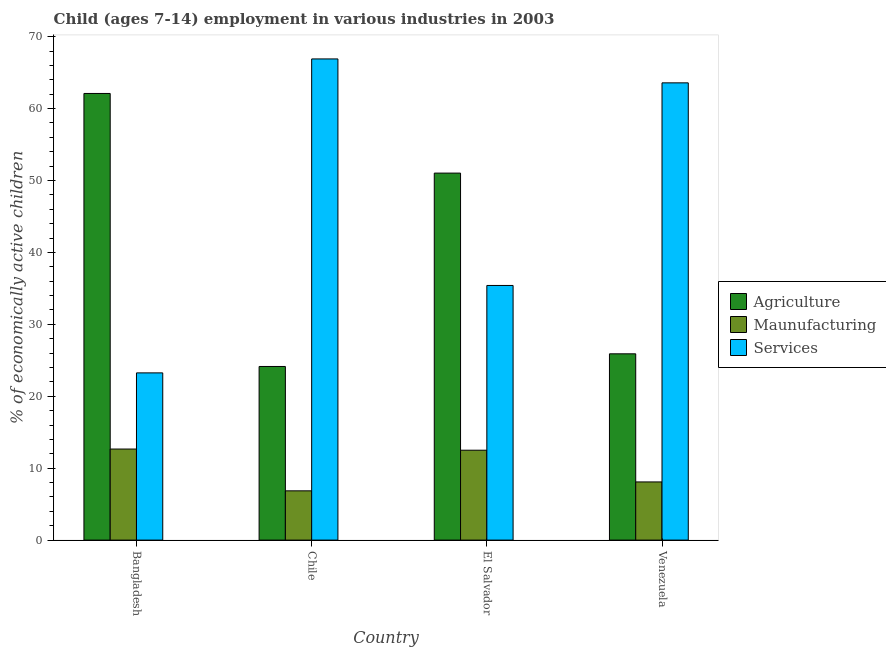How many different coloured bars are there?
Offer a terse response. 3. What is the label of the 2nd group of bars from the left?
Your answer should be compact. Chile. What is the percentage of economically active children in services in El Salvador?
Your answer should be compact. 35.4. Across all countries, what is the maximum percentage of economically active children in agriculture?
Your response must be concise. 62.1. Across all countries, what is the minimum percentage of economically active children in agriculture?
Your response must be concise. 24.14. In which country was the percentage of economically active children in agriculture minimum?
Make the answer very short. Chile. What is the total percentage of economically active children in agriculture in the graph?
Keep it short and to the point. 163.17. What is the difference between the percentage of economically active children in services in Chile and that in El Salvador?
Your answer should be compact. 31.5. What is the difference between the percentage of economically active children in agriculture in Chile and the percentage of economically active children in manufacturing in Venezuela?
Give a very brief answer. 16.05. What is the average percentage of economically active children in agriculture per country?
Your response must be concise. 40.79. What is the difference between the percentage of economically active children in services and percentage of economically active children in agriculture in Bangladesh?
Ensure brevity in your answer.  -38.85. In how many countries, is the percentage of economically active children in agriculture greater than 14 %?
Provide a short and direct response. 4. What is the ratio of the percentage of economically active children in agriculture in El Salvador to that in Venezuela?
Provide a succinct answer. 1.97. Is the percentage of economically active children in agriculture in Chile less than that in El Salvador?
Your answer should be very brief. Yes. Is the difference between the percentage of economically active children in manufacturing in Chile and Venezuela greater than the difference between the percentage of economically active children in agriculture in Chile and Venezuela?
Offer a terse response. Yes. What is the difference between the highest and the second highest percentage of economically active children in manufacturing?
Your response must be concise. 0.16. What is the difference between the highest and the lowest percentage of economically active children in agriculture?
Your response must be concise. 37.96. In how many countries, is the percentage of economically active children in manufacturing greater than the average percentage of economically active children in manufacturing taken over all countries?
Provide a short and direct response. 2. Is the sum of the percentage of economically active children in manufacturing in Bangladesh and Chile greater than the maximum percentage of economically active children in agriculture across all countries?
Your answer should be compact. No. What does the 1st bar from the left in Bangladesh represents?
Your response must be concise. Agriculture. What does the 2nd bar from the right in Venezuela represents?
Your answer should be very brief. Maunufacturing. Are all the bars in the graph horizontal?
Your answer should be very brief. No. How many countries are there in the graph?
Offer a terse response. 4. What is the difference between two consecutive major ticks on the Y-axis?
Provide a short and direct response. 10. Are the values on the major ticks of Y-axis written in scientific E-notation?
Make the answer very short. No. What is the title of the graph?
Make the answer very short. Child (ages 7-14) employment in various industries in 2003. Does "Other sectors" appear as one of the legend labels in the graph?
Provide a succinct answer. No. What is the label or title of the X-axis?
Offer a terse response. Country. What is the label or title of the Y-axis?
Ensure brevity in your answer.  % of economically active children. What is the % of economically active children of Agriculture in Bangladesh?
Your answer should be compact. 62.1. What is the % of economically active children in Maunufacturing in Bangladesh?
Offer a very short reply. 12.66. What is the % of economically active children of Services in Bangladesh?
Provide a short and direct response. 23.25. What is the % of economically active children in Agriculture in Chile?
Your response must be concise. 24.14. What is the % of economically active children in Maunufacturing in Chile?
Your response must be concise. 6.85. What is the % of economically active children of Services in Chile?
Provide a short and direct response. 66.9. What is the % of economically active children of Agriculture in El Salvador?
Provide a succinct answer. 51.03. What is the % of economically active children of Maunufacturing in El Salvador?
Your response must be concise. 12.5. What is the % of economically active children in Services in El Salvador?
Ensure brevity in your answer.  35.4. What is the % of economically active children of Agriculture in Venezuela?
Provide a succinct answer. 25.9. What is the % of economically active children of Maunufacturing in Venezuela?
Keep it short and to the point. 8.09. What is the % of economically active children of Services in Venezuela?
Provide a succinct answer. 63.57. Across all countries, what is the maximum % of economically active children of Agriculture?
Your response must be concise. 62.1. Across all countries, what is the maximum % of economically active children in Maunufacturing?
Ensure brevity in your answer.  12.66. Across all countries, what is the maximum % of economically active children in Services?
Give a very brief answer. 66.9. Across all countries, what is the minimum % of economically active children in Agriculture?
Keep it short and to the point. 24.14. Across all countries, what is the minimum % of economically active children of Maunufacturing?
Make the answer very short. 6.85. Across all countries, what is the minimum % of economically active children in Services?
Make the answer very short. 23.25. What is the total % of economically active children in Agriculture in the graph?
Make the answer very short. 163.17. What is the total % of economically active children in Maunufacturing in the graph?
Provide a short and direct response. 40.1. What is the total % of economically active children in Services in the graph?
Ensure brevity in your answer.  189.13. What is the difference between the % of economically active children of Agriculture in Bangladesh and that in Chile?
Give a very brief answer. 37.96. What is the difference between the % of economically active children of Maunufacturing in Bangladesh and that in Chile?
Ensure brevity in your answer.  5.81. What is the difference between the % of economically active children of Services in Bangladesh and that in Chile?
Provide a short and direct response. -43.65. What is the difference between the % of economically active children in Agriculture in Bangladesh and that in El Salvador?
Ensure brevity in your answer.  11.07. What is the difference between the % of economically active children of Maunufacturing in Bangladesh and that in El Salvador?
Give a very brief answer. 0.16. What is the difference between the % of economically active children in Services in Bangladesh and that in El Salvador?
Make the answer very short. -12.15. What is the difference between the % of economically active children in Agriculture in Bangladesh and that in Venezuela?
Provide a succinct answer. 36.2. What is the difference between the % of economically active children in Maunufacturing in Bangladesh and that in Venezuela?
Offer a very short reply. 4.57. What is the difference between the % of economically active children of Services in Bangladesh and that in Venezuela?
Your answer should be very brief. -40.32. What is the difference between the % of economically active children of Agriculture in Chile and that in El Salvador?
Your response must be concise. -26.89. What is the difference between the % of economically active children of Maunufacturing in Chile and that in El Salvador?
Your answer should be very brief. -5.65. What is the difference between the % of economically active children of Services in Chile and that in El Salvador?
Make the answer very short. 31.5. What is the difference between the % of economically active children in Agriculture in Chile and that in Venezuela?
Give a very brief answer. -1.76. What is the difference between the % of economically active children in Maunufacturing in Chile and that in Venezuela?
Offer a terse response. -1.24. What is the difference between the % of economically active children of Services in Chile and that in Venezuela?
Your answer should be very brief. 3.33. What is the difference between the % of economically active children of Agriculture in El Salvador and that in Venezuela?
Give a very brief answer. 25.13. What is the difference between the % of economically active children in Maunufacturing in El Salvador and that in Venezuela?
Offer a very short reply. 4.41. What is the difference between the % of economically active children in Services in El Salvador and that in Venezuela?
Make the answer very short. -28.17. What is the difference between the % of economically active children of Agriculture in Bangladesh and the % of economically active children of Maunufacturing in Chile?
Ensure brevity in your answer.  55.25. What is the difference between the % of economically active children in Agriculture in Bangladesh and the % of economically active children in Services in Chile?
Provide a succinct answer. -4.8. What is the difference between the % of economically active children of Maunufacturing in Bangladesh and the % of economically active children of Services in Chile?
Offer a terse response. -54.24. What is the difference between the % of economically active children in Agriculture in Bangladesh and the % of economically active children in Maunufacturing in El Salvador?
Your answer should be very brief. 49.6. What is the difference between the % of economically active children in Agriculture in Bangladesh and the % of economically active children in Services in El Salvador?
Keep it short and to the point. 26.7. What is the difference between the % of economically active children in Maunufacturing in Bangladesh and the % of economically active children in Services in El Salvador?
Your answer should be very brief. -22.74. What is the difference between the % of economically active children of Agriculture in Bangladesh and the % of economically active children of Maunufacturing in Venezuela?
Provide a short and direct response. 54.01. What is the difference between the % of economically active children of Agriculture in Bangladesh and the % of economically active children of Services in Venezuela?
Your response must be concise. -1.47. What is the difference between the % of economically active children of Maunufacturing in Bangladesh and the % of economically active children of Services in Venezuela?
Provide a short and direct response. -50.91. What is the difference between the % of economically active children in Agriculture in Chile and the % of economically active children in Maunufacturing in El Salvador?
Give a very brief answer. 11.64. What is the difference between the % of economically active children in Agriculture in Chile and the % of economically active children in Services in El Salvador?
Offer a very short reply. -11.26. What is the difference between the % of economically active children of Maunufacturing in Chile and the % of economically active children of Services in El Salvador?
Your answer should be compact. -28.55. What is the difference between the % of economically active children of Agriculture in Chile and the % of economically active children of Maunufacturing in Venezuela?
Your answer should be compact. 16.05. What is the difference between the % of economically active children in Agriculture in Chile and the % of economically active children in Services in Venezuela?
Your answer should be compact. -39.43. What is the difference between the % of economically active children in Maunufacturing in Chile and the % of economically active children in Services in Venezuela?
Ensure brevity in your answer.  -56.72. What is the difference between the % of economically active children in Agriculture in El Salvador and the % of economically active children in Maunufacturing in Venezuela?
Give a very brief answer. 42.94. What is the difference between the % of economically active children in Agriculture in El Salvador and the % of economically active children in Services in Venezuela?
Offer a very short reply. -12.55. What is the difference between the % of economically active children in Maunufacturing in El Salvador and the % of economically active children in Services in Venezuela?
Your answer should be very brief. -51.07. What is the average % of economically active children in Agriculture per country?
Your answer should be compact. 40.79. What is the average % of economically active children in Maunufacturing per country?
Ensure brevity in your answer.  10.02. What is the average % of economically active children in Services per country?
Provide a succinct answer. 47.28. What is the difference between the % of economically active children of Agriculture and % of economically active children of Maunufacturing in Bangladesh?
Your answer should be very brief. 49.44. What is the difference between the % of economically active children of Agriculture and % of economically active children of Services in Bangladesh?
Offer a very short reply. 38.85. What is the difference between the % of economically active children in Maunufacturing and % of economically active children in Services in Bangladesh?
Ensure brevity in your answer.  -10.59. What is the difference between the % of economically active children of Agriculture and % of economically active children of Maunufacturing in Chile?
Offer a very short reply. 17.29. What is the difference between the % of economically active children of Agriculture and % of economically active children of Services in Chile?
Your answer should be compact. -42.76. What is the difference between the % of economically active children in Maunufacturing and % of economically active children in Services in Chile?
Ensure brevity in your answer.  -60.05. What is the difference between the % of economically active children in Agriculture and % of economically active children in Maunufacturing in El Salvador?
Your response must be concise. 38.53. What is the difference between the % of economically active children of Agriculture and % of economically active children of Services in El Salvador?
Offer a very short reply. 15.62. What is the difference between the % of economically active children of Maunufacturing and % of economically active children of Services in El Salvador?
Offer a very short reply. -22.9. What is the difference between the % of economically active children of Agriculture and % of economically active children of Maunufacturing in Venezuela?
Ensure brevity in your answer.  17.81. What is the difference between the % of economically active children of Agriculture and % of economically active children of Services in Venezuela?
Provide a short and direct response. -37.67. What is the difference between the % of economically active children of Maunufacturing and % of economically active children of Services in Venezuela?
Give a very brief answer. -55.49. What is the ratio of the % of economically active children of Agriculture in Bangladesh to that in Chile?
Ensure brevity in your answer.  2.57. What is the ratio of the % of economically active children in Maunufacturing in Bangladesh to that in Chile?
Offer a terse response. 1.85. What is the ratio of the % of economically active children in Services in Bangladesh to that in Chile?
Make the answer very short. 0.35. What is the ratio of the % of economically active children of Agriculture in Bangladesh to that in El Salvador?
Your answer should be very brief. 1.22. What is the ratio of the % of economically active children in Maunufacturing in Bangladesh to that in El Salvador?
Your response must be concise. 1.01. What is the ratio of the % of economically active children in Services in Bangladesh to that in El Salvador?
Ensure brevity in your answer.  0.66. What is the ratio of the % of economically active children of Agriculture in Bangladesh to that in Venezuela?
Your response must be concise. 2.4. What is the ratio of the % of economically active children in Maunufacturing in Bangladesh to that in Venezuela?
Keep it short and to the point. 1.57. What is the ratio of the % of economically active children of Services in Bangladesh to that in Venezuela?
Offer a very short reply. 0.37. What is the ratio of the % of economically active children of Agriculture in Chile to that in El Salvador?
Give a very brief answer. 0.47. What is the ratio of the % of economically active children of Maunufacturing in Chile to that in El Salvador?
Provide a succinct answer. 0.55. What is the ratio of the % of economically active children of Services in Chile to that in El Salvador?
Your answer should be compact. 1.89. What is the ratio of the % of economically active children in Agriculture in Chile to that in Venezuela?
Your answer should be compact. 0.93. What is the ratio of the % of economically active children in Maunufacturing in Chile to that in Venezuela?
Give a very brief answer. 0.85. What is the ratio of the % of economically active children of Services in Chile to that in Venezuela?
Provide a succinct answer. 1.05. What is the ratio of the % of economically active children in Agriculture in El Salvador to that in Venezuela?
Your response must be concise. 1.97. What is the ratio of the % of economically active children in Maunufacturing in El Salvador to that in Venezuela?
Your answer should be compact. 1.55. What is the ratio of the % of economically active children in Services in El Salvador to that in Venezuela?
Give a very brief answer. 0.56. What is the difference between the highest and the second highest % of economically active children in Agriculture?
Provide a short and direct response. 11.07. What is the difference between the highest and the second highest % of economically active children in Maunufacturing?
Ensure brevity in your answer.  0.16. What is the difference between the highest and the second highest % of economically active children of Services?
Make the answer very short. 3.33. What is the difference between the highest and the lowest % of economically active children in Agriculture?
Your response must be concise. 37.96. What is the difference between the highest and the lowest % of economically active children in Maunufacturing?
Keep it short and to the point. 5.81. What is the difference between the highest and the lowest % of economically active children in Services?
Offer a very short reply. 43.65. 